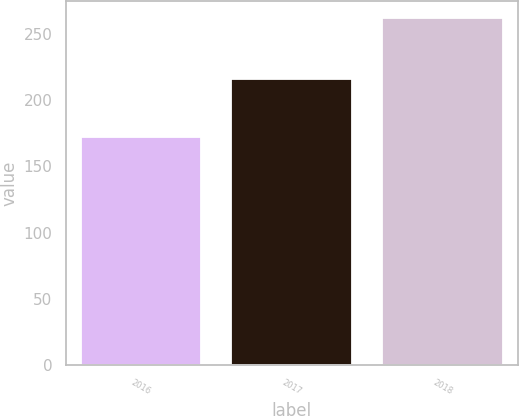Convert chart to OTSL. <chart><loc_0><loc_0><loc_500><loc_500><bar_chart><fcel>2016<fcel>2017<fcel>2018<nl><fcel>172<fcel>216<fcel>262<nl></chart> 